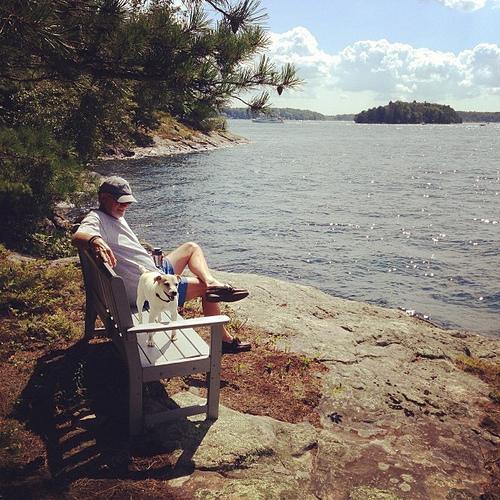How many people are there?
Give a very brief answer. 1. How many people are on the bench?
Give a very brief answer. 1. 